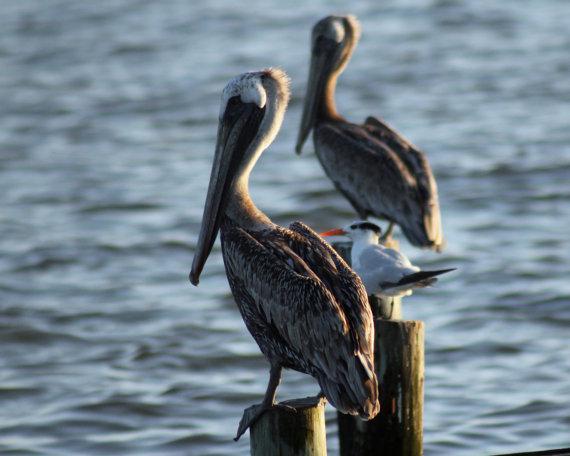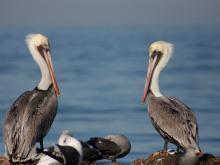The first image is the image on the left, the second image is the image on the right. Given the left and right images, does the statement "An image shows only two birds, which are overlapped facing each other so their heads and necks form a heart shape." hold true? Answer yes or no. No. 